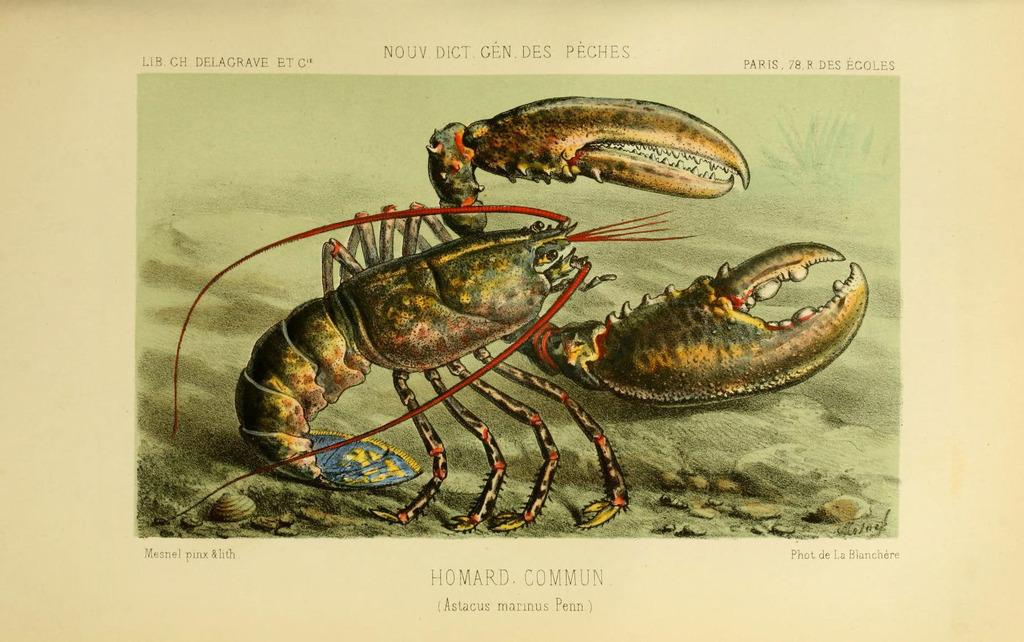What type of animal is depicted in the image? The image is a graphical representation of an American lobster. Can you describe any specific features of the lobster in the image? The image shows the lobster's claws, antennae, and segmented body. How many baseballs can be seen in the image? There are no baseballs present in the image; it is a graphical representation of an American lobster. What type of eggs are used to make the lobster's shell in the image? The image is a graphical representation, and the lobster's shell is not made of eggs. 